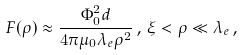<formula> <loc_0><loc_0><loc_500><loc_500>F ( \rho ) \approx \frac { \Phi _ { 0 } ^ { 2 } d } { 4 \pi \mu _ { 0 } \lambda _ { e } \rho ^ { 2 } } \, , \, \xi < \rho \ll \lambda _ { e } \, ,</formula> 